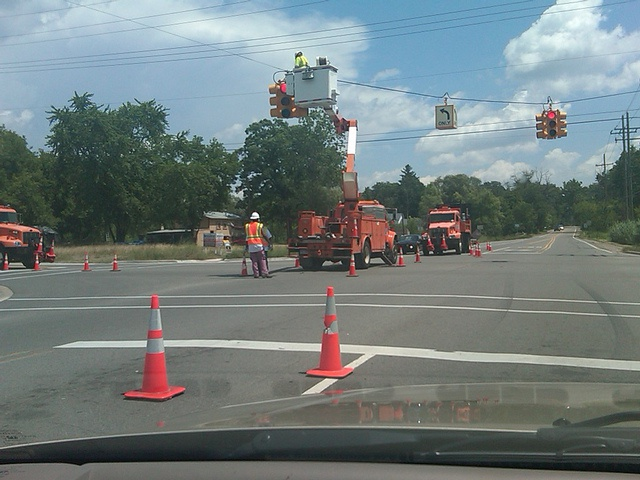Describe the objects in this image and their specific colors. I can see truck in darkgray, gray, black, maroon, and brown tones, truck in darkgray, black, maroon, gray, and brown tones, truck in darkgray, black, maroon, brown, and gray tones, people in darkgray, gray, black, and salmon tones, and traffic light in darkgray, gray, darkblue, purple, and black tones in this image. 